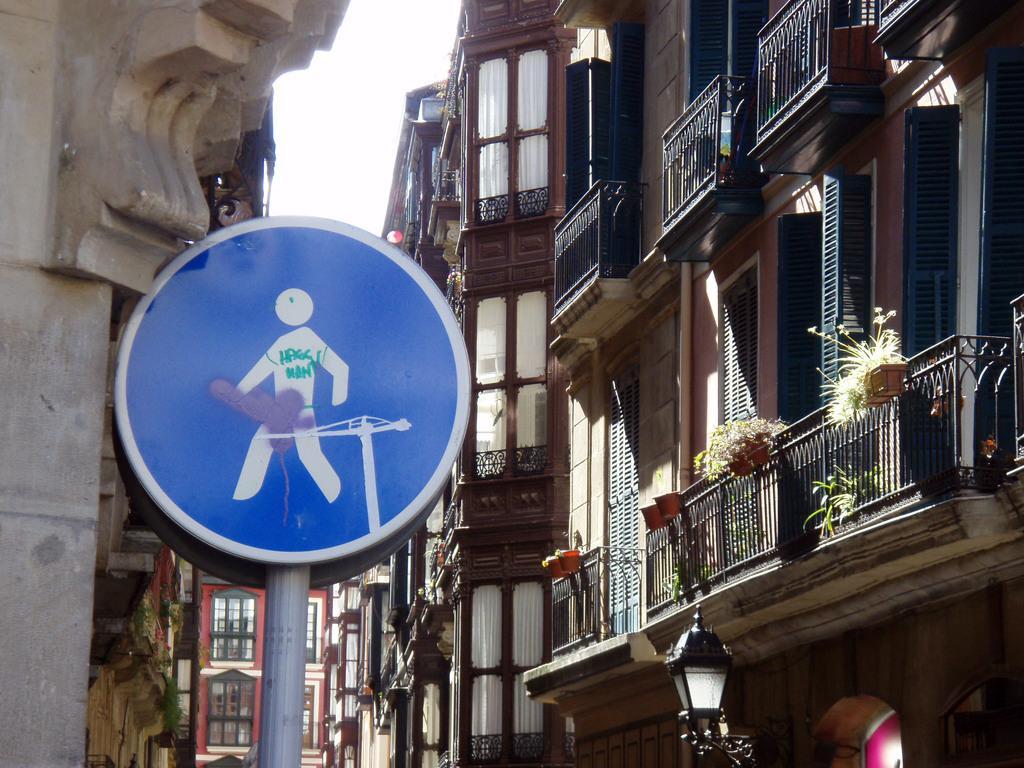In one or two sentences, can you explain what this image depicts? In this image we can see buildings, sign boards, grills, houseplants, street lights and sky. 